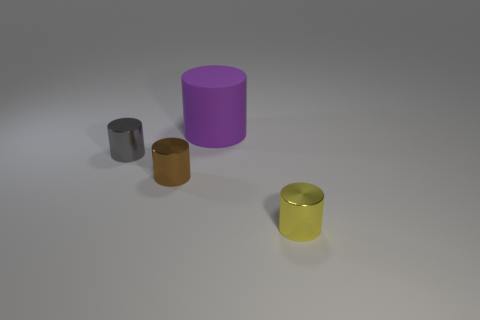Add 1 yellow metallic cylinders. How many objects exist? 5 Add 3 gray things. How many gray things are left? 4 Add 4 small cyan cylinders. How many small cyan cylinders exist? 4 Subtract 0 blue spheres. How many objects are left? 4 Subtract all large red spheres. Subtract all cylinders. How many objects are left? 0 